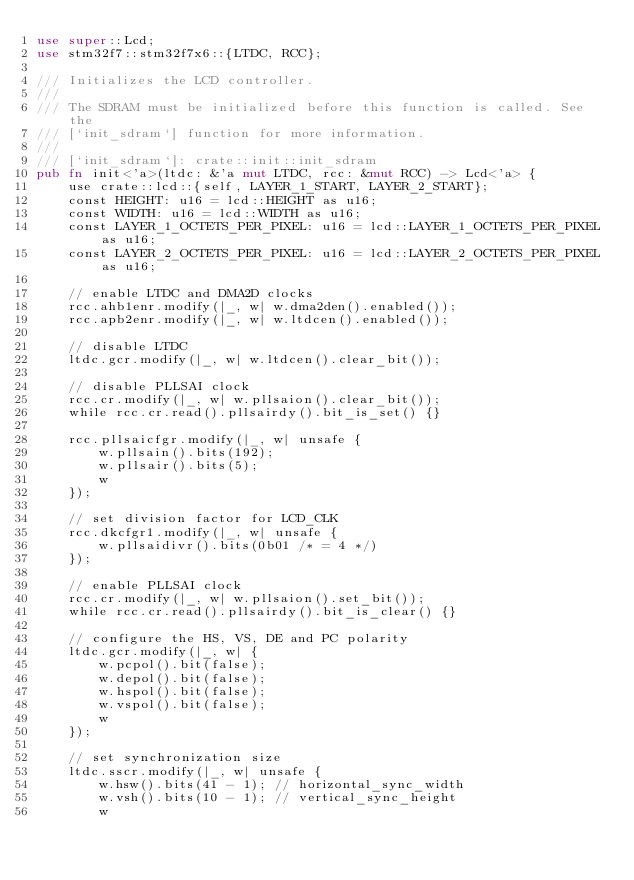Convert code to text. <code><loc_0><loc_0><loc_500><loc_500><_Rust_>use super::Lcd;
use stm32f7::stm32f7x6::{LTDC, RCC};

/// Initializes the LCD controller.
///
/// The SDRAM must be initialized before this function is called. See the
/// [`init_sdram`] function for more information.
///
/// [`init_sdram`]: crate::init::init_sdram
pub fn init<'a>(ltdc: &'a mut LTDC, rcc: &mut RCC) -> Lcd<'a> {
    use crate::lcd::{self, LAYER_1_START, LAYER_2_START};
    const HEIGHT: u16 = lcd::HEIGHT as u16;
    const WIDTH: u16 = lcd::WIDTH as u16;
    const LAYER_1_OCTETS_PER_PIXEL: u16 = lcd::LAYER_1_OCTETS_PER_PIXEL as u16;
    const LAYER_2_OCTETS_PER_PIXEL: u16 = lcd::LAYER_2_OCTETS_PER_PIXEL as u16;

    // enable LTDC and DMA2D clocks
    rcc.ahb1enr.modify(|_, w| w.dma2den().enabled());
    rcc.apb2enr.modify(|_, w| w.ltdcen().enabled());

    // disable LTDC
    ltdc.gcr.modify(|_, w| w.ltdcen().clear_bit());

    // disable PLLSAI clock
    rcc.cr.modify(|_, w| w.pllsaion().clear_bit());
    while rcc.cr.read().pllsairdy().bit_is_set() {}

    rcc.pllsaicfgr.modify(|_, w| unsafe {
        w.pllsain().bits(192);
        w.pllsair().bits(5);
        w
    });

    // set division factor for LCD_CLK
    rcc.dkcfgr1.modify(|_, w| unsafe {
        w.pllsaidivr().bits(0b01 /* = 4 */)
    });

    // enable PLLSAI clock
    rcc.cr.modify(|_, w| w.pllsaion().set_bit());
    while rcc.cr.read().pllsairdy().bit_is_clear() {}

    // configure the HS, VS, DE and PC polarity
    ltdc.gcr.modify(|_, w| {
        w.pcpol().bit(false);
        w.depol().bit(false);
        w.hspol().bit(false);
        w.vspol().bit(false);
        w
    });

    // set synchronization size
    ltdc.sscr.modify(|_, w| unsafe {
        w.hsw().bits(41 - 1); // horizontal_sync_width
        w.vsh().bits(10 - 1); // vertical_sync_height
        w</code> 